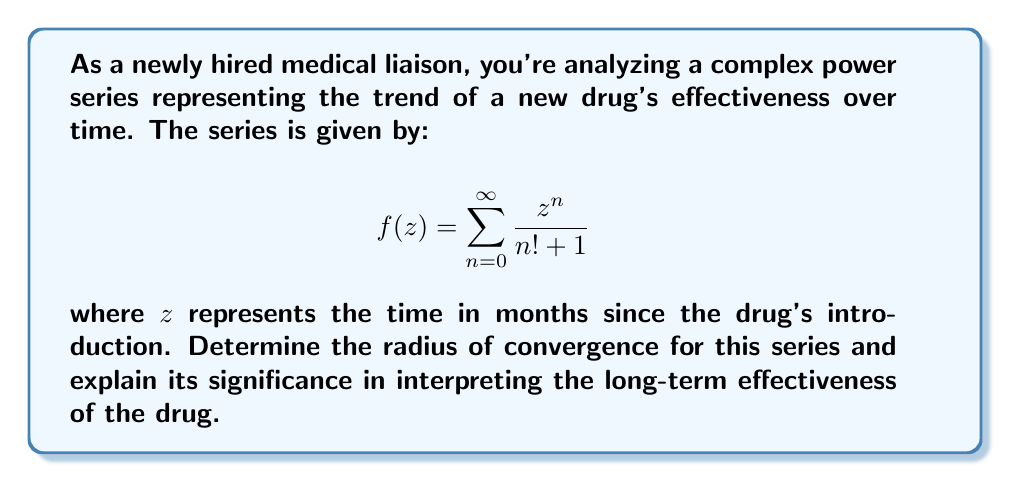Can you answer this question? To determine the radius of convergence for this complex power series, we'll use the ratio test:

1) First, let's define $a_n = \frac{1}{n! + 1}$

2) Apply the ratio test:
   $$\lim_{n \to \infty} \left|\frac{a_{n+1}}{a_n}\right| = \lim_{n \to \infty} \left|\frac{n! + 1}{(n+1)! + 1}\right|$$

3) Simplify:
   $$\lim_{n \to \infty} \left|\frac{n! + 1}{(n+1)(n! + 1)}\right| = \lim_{n \to \infty} \left|\frac{1}{n+1}\right|$$

4) Evaluate the limit:
   $$\lim_{n \to \infty} \frac{1}{n+1} = 0$$

5) The radius of convergence $R$ is given by:
   $$R = \frac{1}{\lim_{n \to \infty} \left|\frac{a_{n+1}}{a_n}\right|} = \frac{1}{0} = \infty$$

Significance:
The infinite radius of convergence indicates that the series converges for all complex values of $z$. In the context of drug effectiveness, this suggests that the mathematical model predicts the drug's effectiveness can be analyzed for any time period, even far into the future. However, it's important to note that while mathematically valid, real-world factors may limit the practical applicability of this model over extended periods.
Answer: $R = \infty$ 